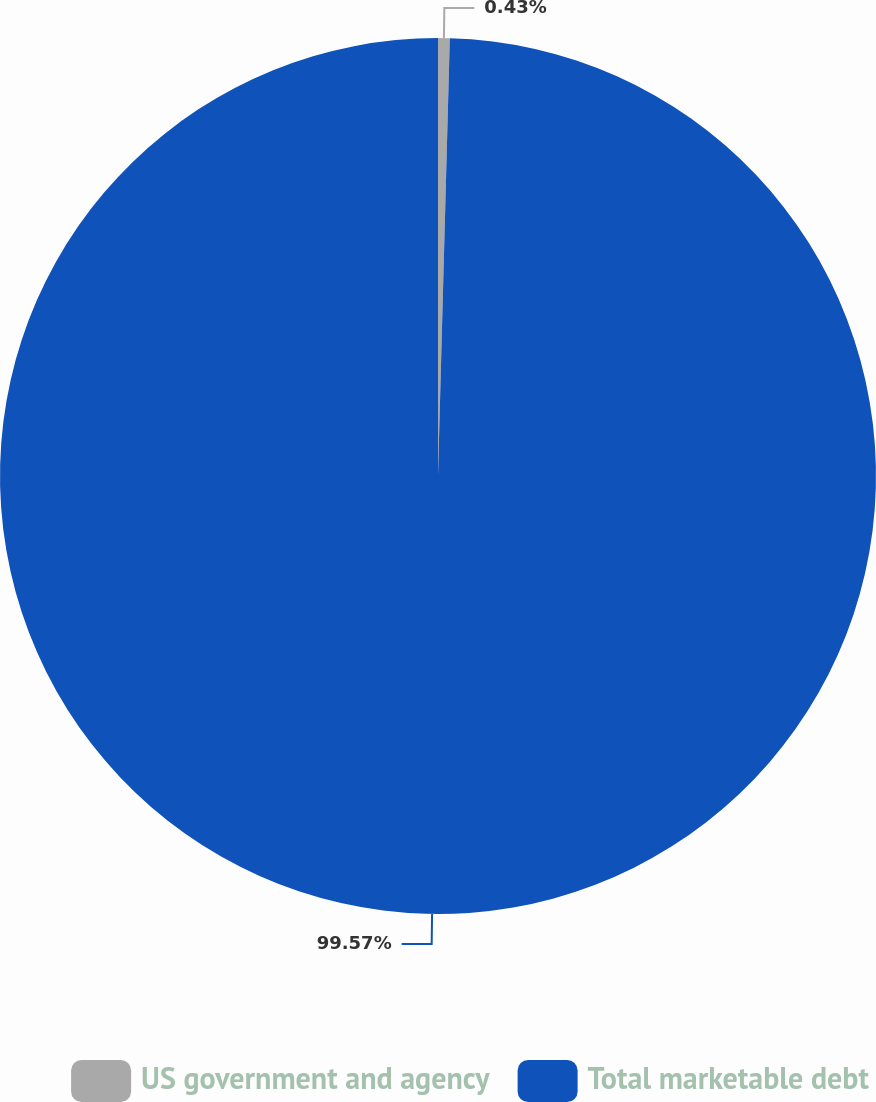<chart> <loc_0><loc_0><loc_500><loc_500><pie_chart><fcel>US government and agency<fcel>Total marketable debt<nl><fcel>0.43%<fcel>99.57%<nl></chart> 